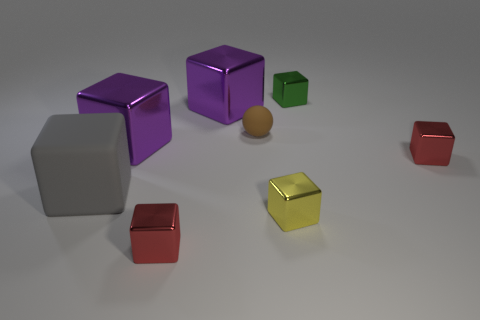Subtract all tiny yellow metallic blocks. How many blocks are left? 6 Subtract all red cubes. How many cubes are left? 5 Subtract 6 cubes. How many cubes are left? 1 Subtract all blocks. How many objects are left? 1 Subtract all green balls. How many gray cubes are left? 1 Add 1 purple shiny cubes. How many objects exist? 9 Subtract all green balls. Subtract all brown cubes. How many balls are left? 1 Subtract all brown matte objects. Subtract all large yellow metal cubes. How many objects are left? 7 Add 4 big things. How many big things are left? 7 Add 6 blue metal objects. How many blue metal objects exist? 6 